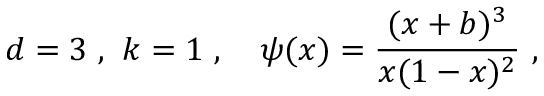<formula> <loc_0><loc_0><loc_500><loc_500>d = 3 \ , \ k = 1 \ , \quad p s i ( x ) = \frac { ( x + b ) ^ { 3 } } { x ( 1 - x ) ^ { 2 } } \ ,</formula> 